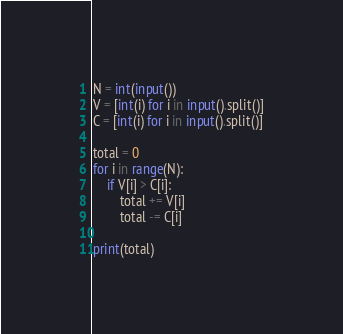<code> <loc_0><loc_0><loc_500><loc_500><_Python_>N = int(input())
V = [int(i) for i in input().split()]
C = [int(i) for i in input().split()]

total = 0
for i in range(N):
    if V[i] > C[i]:
        total += V[i]
        total -= C[i]
        
print(total)</code> 